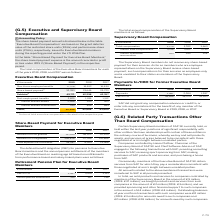According to Sap Ag's financial document, What was the total compensation in 2019? According to the financial document, 3,770 (in thousands). The relevant text states: "Total compensation 3,770 3,702 3,663..." Also, What was the  Thereof committee remuneration  in 2018? According to the financial document, 540 (in thousands). The relevant text states: "553 540 528..." Also, In which years was the total annual compensation calculated in? The document contains multiple relevant values: 2019, 2018, 2017. From the document: "€ thousands 2019 2018 2017 € thousands 2019 2018 2017 € thousands 2019 2018 2017..." Additionally, In which year was the amount Thereof committee remuneration the largest? According to the financial document, 2019. The relevant text states: "€ thousands 2019 2018 2017..." Also, can you calculate: What was the change in the amount Thereof committee remuneration in 2019 from 2018? Based on the calculation: 553-540, the result is 13 (in thousands). This is based on the information: "553 540 528 553 540 528..." The key data points involved are: 540, 553. Also, can you calculate: What was the percentage change in the amount Thereof committee remuneration in 2019 from 2018? To answer this question, I need to perform calculations using the financial data. The calculation is: (553-540)/540, which equals 2.41 (percentage). This is based on the information: "553 540 528 553 540 528..." The key data points involved are: 540, 553. 